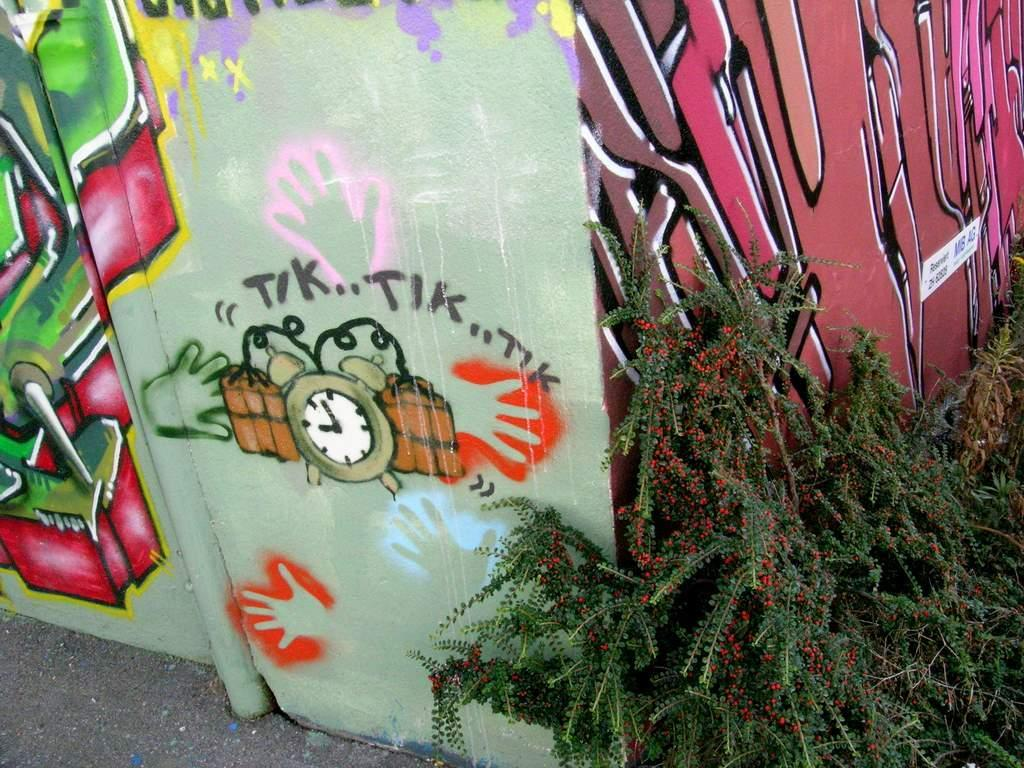What type of vegetation is on the right side of the image? There are plants on the right side of the image. What can be seen on the wall in the image? There is a wall with graffiti in the image. Where is the mailbox located in the image? There is no mailbox present in the image. What type of record is being kept by the plants in the image? The plants in the image are not keeping any records; they are simply vegetation. 